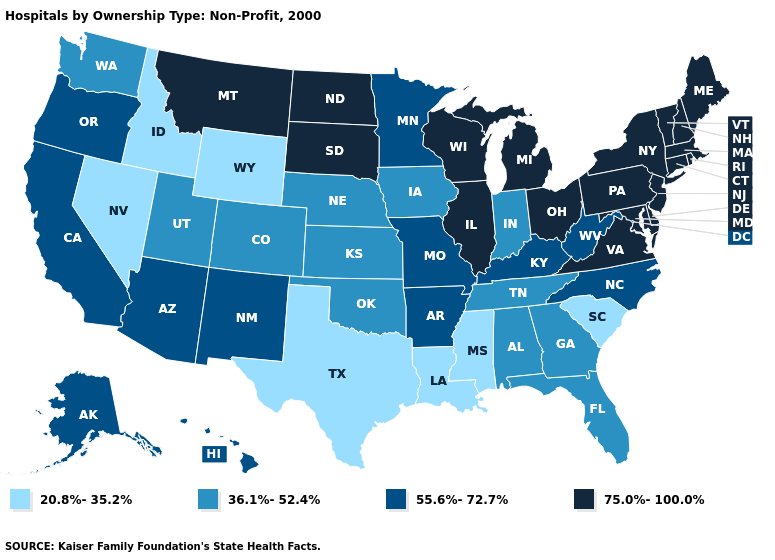Name the states that have a value in the range 36.1%-52.4%?
Write a very short answer. Alabama, Colorado, Florida, Georgia, Indiana, Iowa, Kansas, Nebraska, Oklahoma, Tennessee, Utah, Washington. Does the map have missing data?
Short answer required. No. Does Michigan have the lowest value in the MidWest?
Keep it brief. No. Name the states that have a value in the range 20.8%-35.2%?
Quick response, please. Idaho, Louisiana, Mississippi, Nevada, South Carolina, Texas, Wyoming. Which states hav the highest value in the Northeast?
Answer briefly. Connecticut, Maine, Massachusetts, New Hampshire, New Jersey, New York, Pennsylvania, Rhode Island, Vermont. Does South Dakota have the highest value in the MidWest?
Concise answer only. Yes. Which states have the lowest value in the MidWest?
Keep it brief. Indiana, Iowa, Kansas, Nebraska. Name the states that have a value in the range 36.1%-52.4%?
Answer briefly. Alabama, Colorado, Florida, Georgia, Indiana, Iowa, Kansas, Nebraska, Oklahoma, Tennessee, Utah, Washington. What is the lowest value in states that border Montana?
Answer briefly. 20.8%-35.2%. What is the value of Michigan?
Write a very short answer. 75.0%-100.0%. Name the states that have a value in the range 36.1%-52.4%?
Be succinct. Alabama, Colorado, Florida, Georgia, Indiana, Iowa, Kansas, Nebraska, Oklahoma, Tennessee, Utah, Washington. Does the map have missing data?
Keep it brief. No. Among the states that border Michigan , which have the highest value?
Answer briefly. Ohio, Wisconsin. Does Arizona have the same value as Montana?
Give a very brief answer. No. What is the lowest value in states that border Maine?
Answer briefly. 75.0%-100.0%. 